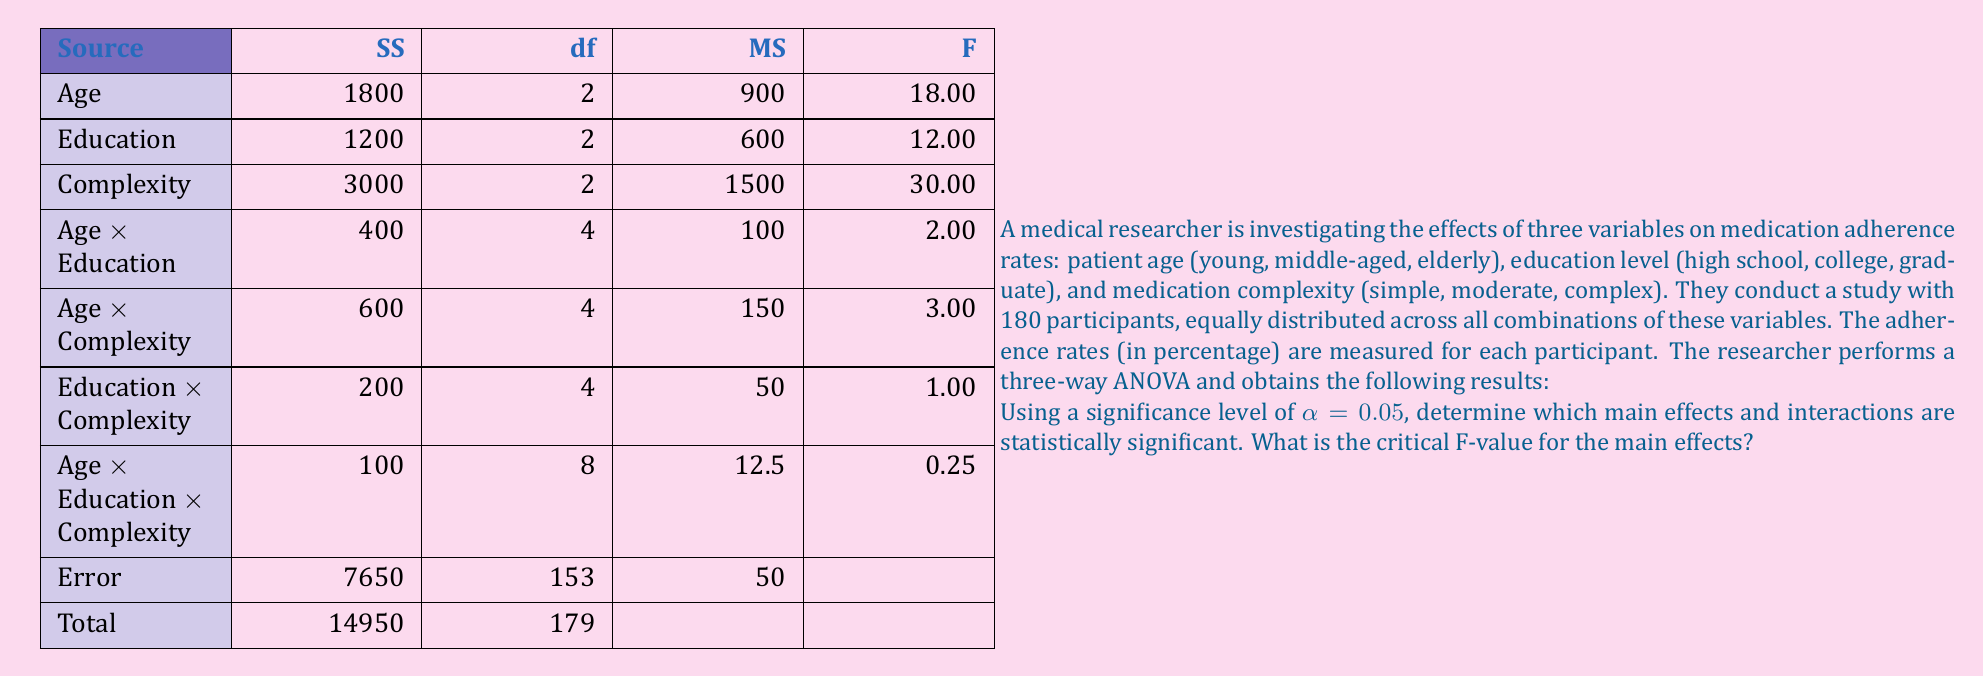Show me your answer to this math problem. To determine which main effects and interactions are statistically significant, we need to compare the calculated F-values with the critical F-values for each effect and interaction.

1. First, let's find the critical F-values:
   - For main effects: $F_{crit}(2, 153, 0.05) = 3.06$
   - For two-way interactions: $F_{crit}(4, 153, 0.05) = 2.43$
   - For three-way interaction: $F_{crit}(8, 153, 0.05) = 2.00$

2. Now, let's compare the calculated F-values with the critical F-values:

   Main effects:
   - Age: $F = 18.00 > 3.06$, significant
   - Education: $F = 12.00 > 3.06$, significant
   - Complexity: $F = 30.00 > 3.06$, significant

   Two-way interactions:
   - Age × Education: $F = 2.00 < 2.43$, not significant
   - Age × Complexity: $F = 3.00 > 2.43$, significant
   - Education × Complexity: $F = 1.00 < 2.43$, not significant

   Three-way interaction:
   - Age × Education × Complexity: $F = 0.25 < 2.00$, not significant

3. Interpretation:
   - All main effects (Age, Education, and Complexity) are statistically significant.
   - Only the Age × Complexity interaction is statistically significant among the two-way interactions.
   - The three-way interaction is not statistically significant.

These results suggest that age, education level, and medication complexity all have significant individual effects on medication adherence rates. Additionally, there is a significant interaction between age and medication complexity, indicating that the effect of medication complexity on adherence rates may differ across age groups.
Answer: The statistically significant effects are:
- Main effects: Age, Education, and Complexity
- Two-way interaction: Age × Complexity

The critical F-value for the main effects is $F_{crit}(2, 153, 0.05) = 3.06$. 